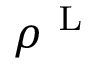<formula> <loc_0><loc_0><loc_500><loc_500>\rho ^ { L }</formula> 